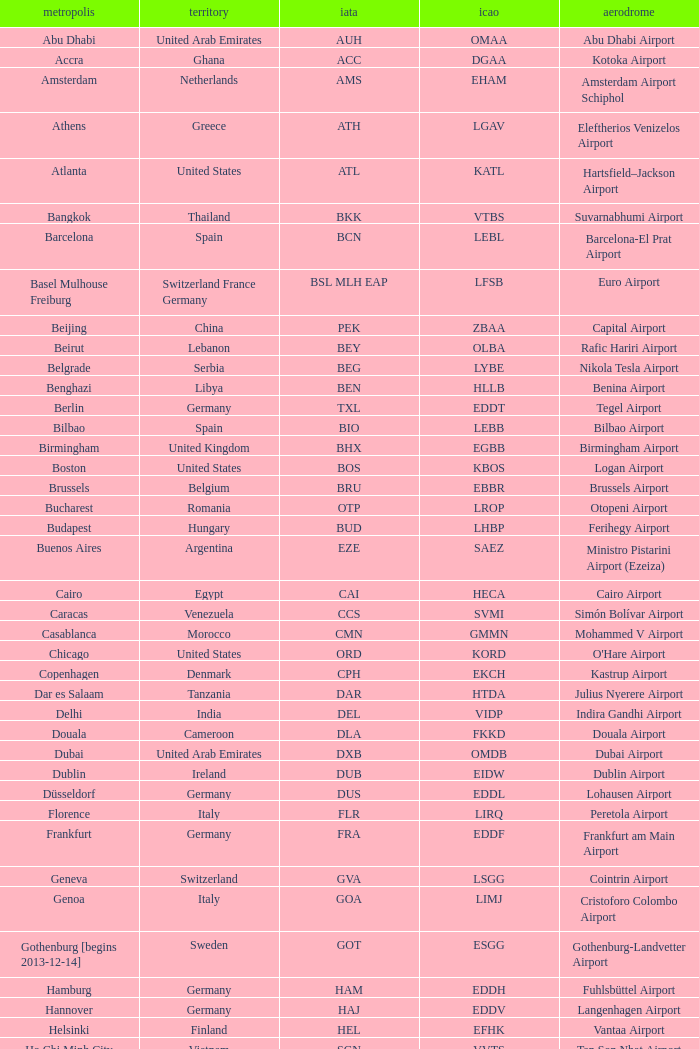Which city has the IATA SSG? Malabo. 